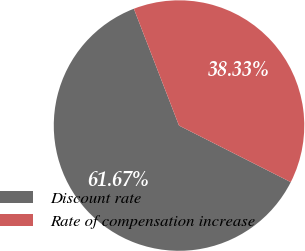Convert chart to OTSL. <chart><loc_0><loc_0><loc_500><loc_500><pie_chart><fcel>Discount rate<fcel>Rate of compensation increase<nl><fcel>61.67%<fcel>38.33%<nl></chart> 